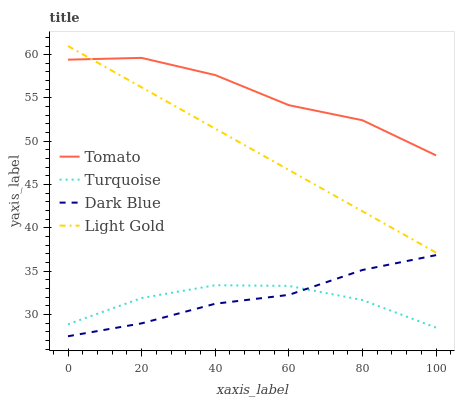Does Turquoise have the minimum area under the curve?
Answer yes or no. Yes. Does Tomato have the maximum area under the curve?
Answer yes or no. Yes. Does Dark Blue have the minimum area under the curve?
Answer yes or no. No. Does Dark Blue have the maximum area under the curve?
Answer yes or no. No. Is Light Gold the smoothest?
Answer yes or no. Yes. Is Tomato the roughest?
Answer yes or no. Yes. Is Dark Blue the smoothest?
Answer yes or no. No. Is Dark Blue the roughest?
Answer yes or no. No. Does Turquoise have the lowest value?
Answer yes or no. No. Does Light Gold have the highest value?
Answer yes or no. Yes. Does Dark Blue have the highest value?
Answer yes or no. No. Is Dark Blue less than Light Gold?
Answer yes or no. Yes. Is Light Gold greater than Turquoise?
Answer yes or no. Yes. Does Turquoise intersect Dark Blue?
Answer yes or no. Yes. Is Turquoise less than Dark Blue?
Answer yes or no. No. Is Turquoise greater than Dark Blue?
Answer yes or no. No. Does Dark Blue intersect Light Gold?
Answer yes or no. No. 